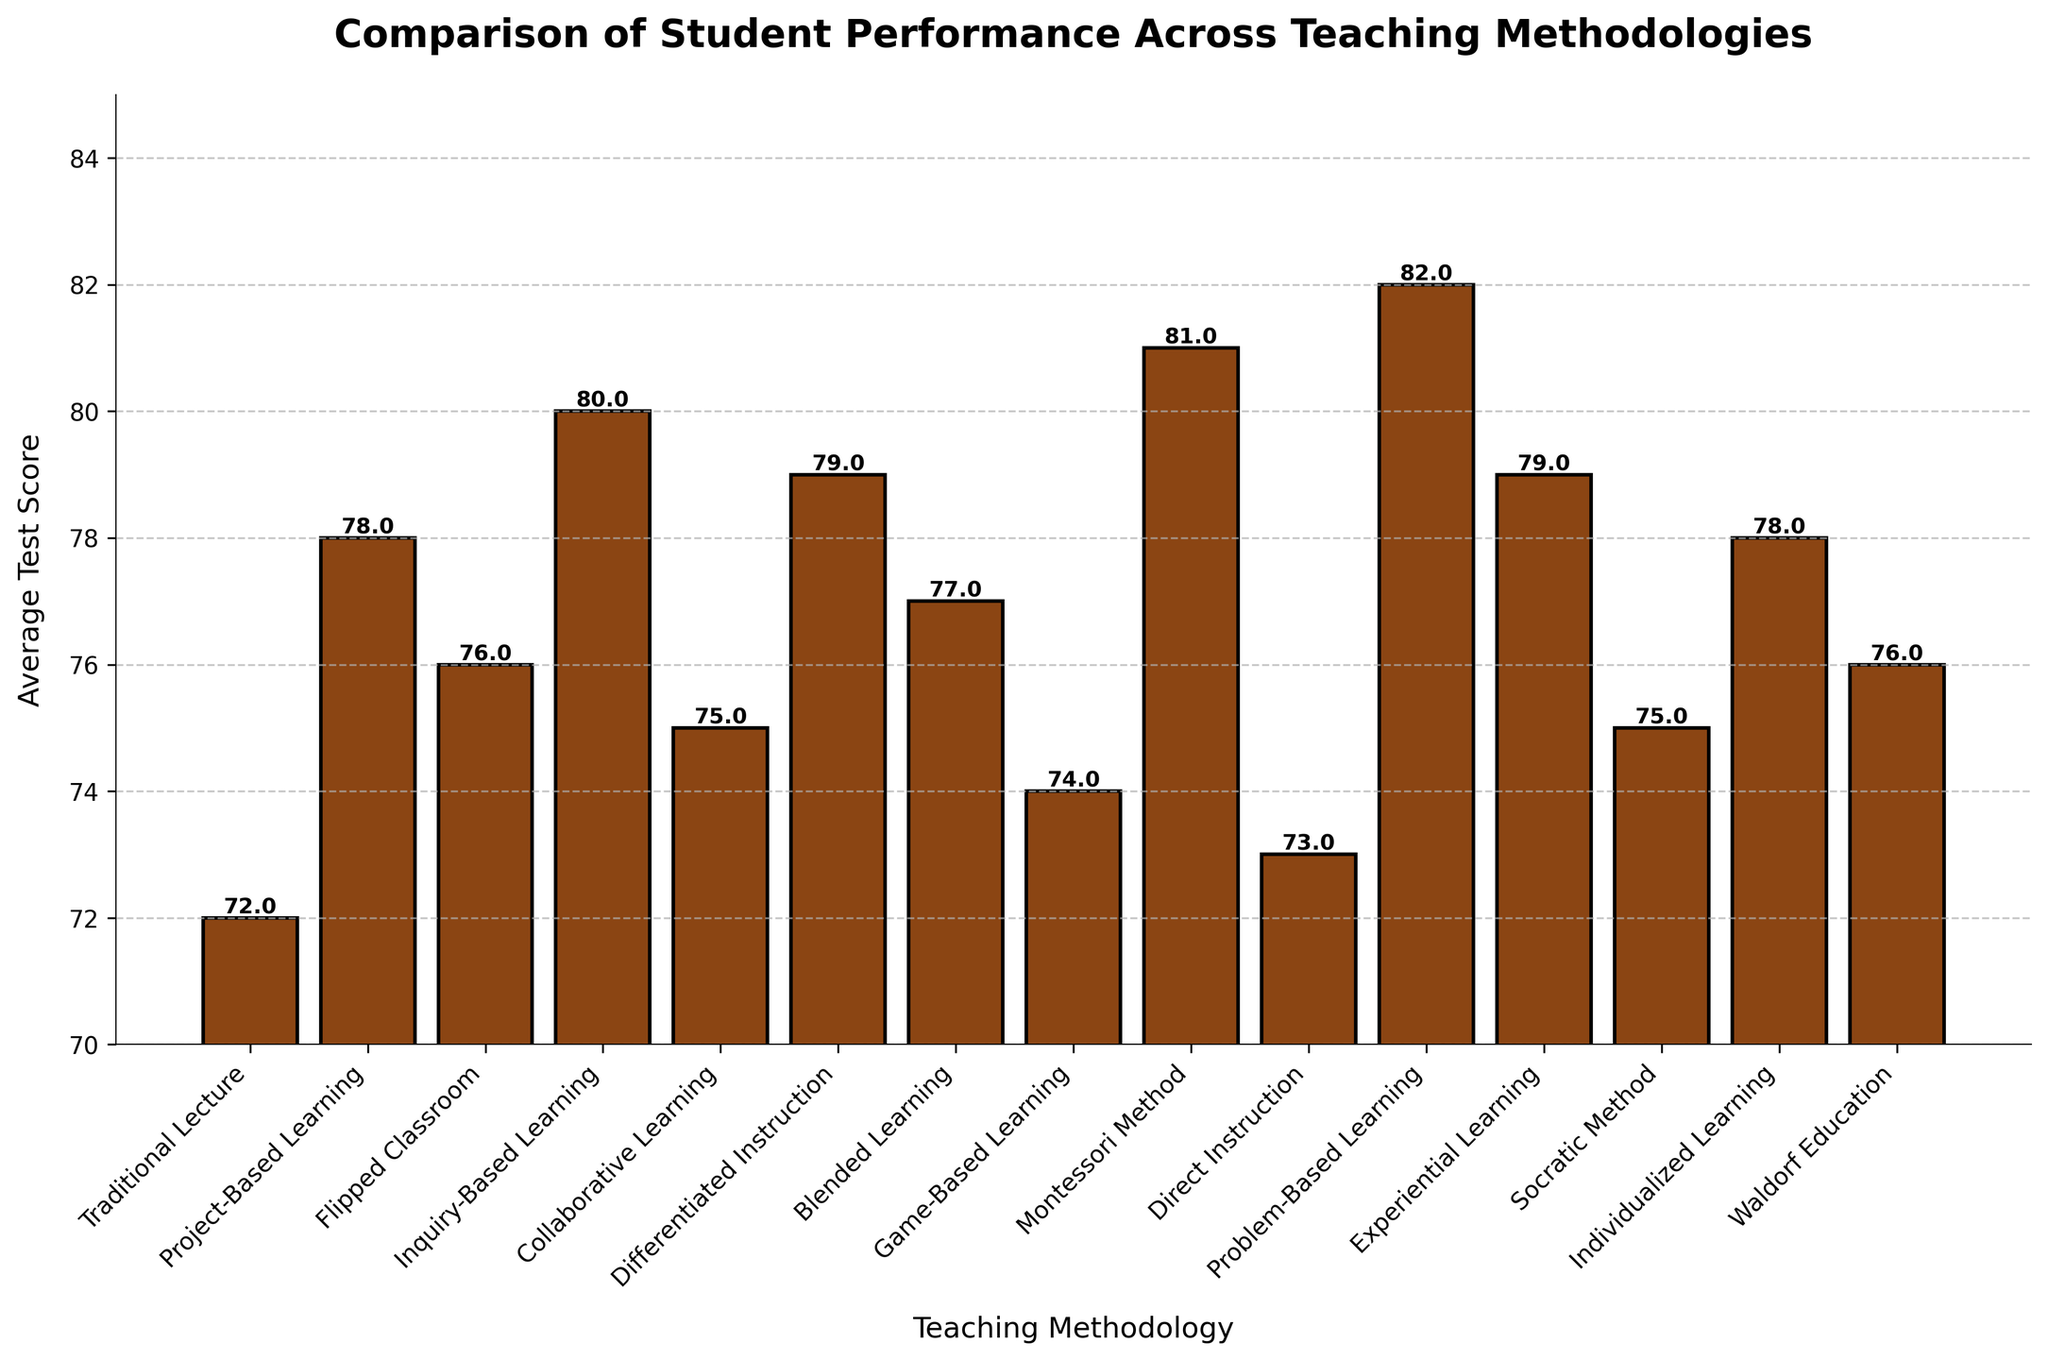Which teaching methodology has the highest average test score? The highest bar in the chart represents the teaching methodology with the highest average test score. By visually inspecting, Problem-Based Learning has the highest bar.
Answer: Problem-Based Learning What’s the average test score difference between Montessori Method and Direct Instruction? The bar height for Montessori Method is 81, and for Direct Instruction is 73. The difference is calculated as 81 - 73.
Answer: 8 Which methodologies have the same average test score? By inspecting the heights of the bars, we see that Collaborative Learning and Socratic Method both have an average test score of 75, and Flipped Classroom and Waldorf Education both have an average test score of 76.
Answer: Collaborative Learning and Socratic Method; Flipped Classroom and Waldorf Education What is the total average test score of all teaching methodologies shown? Sum the average test scores of all the teaching methodologies: 72 + 78 + 76 + 80 + 75 + 79 + 77 + 74 + 81 + 73 + 82 + 79 + 75 + 78 + 76 = 1175.
Answer: 1175 Which teaching methodology shows an average test score closest to the median of all methods? Arrange the average scores in ascending order: 72, 73, 74, 75, 75, 76, 76, 76, 77, 78, 78, 79, 79, 80, 81, 82. The median values are the 8th and 9th in the list, which are both 76. Therefore, the scores closest to 76 are Flipped Classroom and Waldorf Education.
Answer: Flipped Classroom and Waldorf Education What is the range of average test scores across all methodologies? Identify the highest and lowest values: 82 (Problem-Based Learning) and 72 (Traditional Lecture). Calculate the range: 82 - 72.
Answer: 10 Between Project-Based Learning and Game-Based Learning, which methodology has a higher average test score? Compare the heights of the respective bars: Project-Based Learning (78) is higher than Game-Based Learning (74).
Answer: Project-Based Learning What is the average score for methodologies achieving above 79? Identify methodologies with scores above 79: Montessori Method (81), Inquiry-Based Learning (80), Problem-Based Learning (82), Differentiated Instruction (79), and Experiential Learning (79). Calculate the average: (81 + 80 + 82 + 79 + 79) / 5 = 401 / 5 = 80.2.
Answer: 80.2 